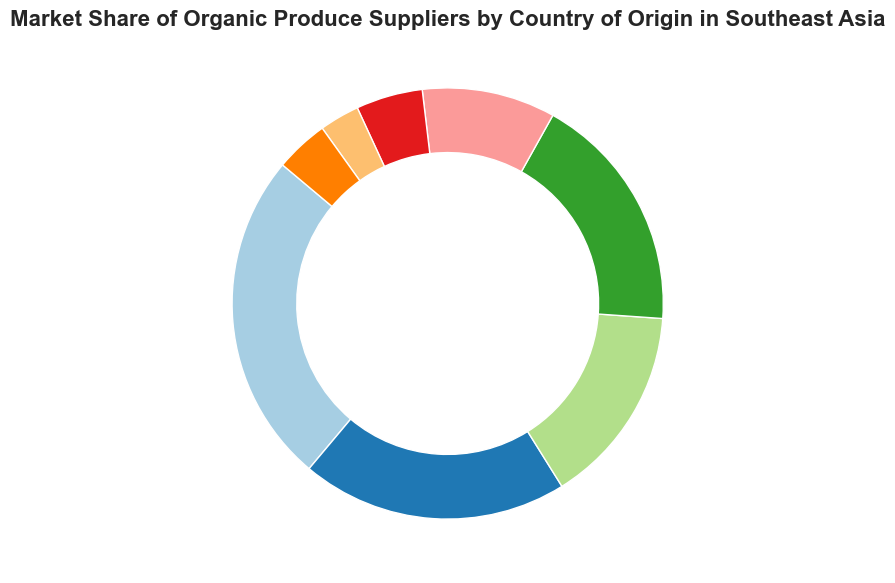What is the market share of Myanmar's organic produce suppliers? Start by looking at the segment of the ring chart labeled "Myanmar." The chart section corresponding to Myanmar displays its market share as a percentage.
Answer: 4% Which country has the largest market share of organic produce suppliers? Identify the segment with the largest proportion. The country with the largest portion is indicating "Thailand" at 25%.
Answer: Thailand Between Indonesia and Malaysia, which country has a higher market share? Compare the sizes of the sections labeled "Indonesia" and "Malaysia." Indonesia's market share is 18%, while Malaysia's is 10%, so Indonesia has the higher market share.
Answer: Indonesia How much larger is Vietnam's market share compared to Cambodia's? Find the percentages for Vietnam and Cambodia. Vietnam is at 20% and Cambodia is at 5%. Subtract Cambodia's market share from Vietnam's: 20% - 5% = 15%.
Answer: 15% What is the combined market share of the countries with the smallest portions (Laos and Myanmar)? Identify the segments for Laos and Myanmar. Laos has a market share of 3% and Myanmar has 4%. Add these together: 3% + 4% = 7%.
Answer: 7% If Thailand's market share was reduced by 5%, what would be its new market share? Thailand's initial market share is 25%. Subtract 5% from this: 25% - 5% = 20%.
Answer: 20% Which countries have less than 10% of the market share? Identify the segments with less than 10%. These are Cambodia (5%), Laos (3%), and Myanmar (4%).
Answer: Cambodia, Laos, Myanmar What is the total market share of countries with more than 15% share each? Look for segments above 15%. These are Thailand (25%), Vietnam (20%), and Indonesia (18%). Add them: 25% + 20% + 18% = 63%.
Answer: 63% How much more market share does the Philippines have compared to Laos? Identify both segments' shares. The Philippines has 15% and Laos has 3%. Subtract Laos' share from the Philippines': 15% - 3% = 12%.
Answer: 12% What is the average market share of Malaysia, Cambodia, and Laos? Identify each percentage first. Malaysia has 10%, Cambodia 5%, and Laos 3%. Sum these up and divide by 3: (10% + 5% + 3%) / 3 = 18% / 3 = 6%.
Answer: 6% 